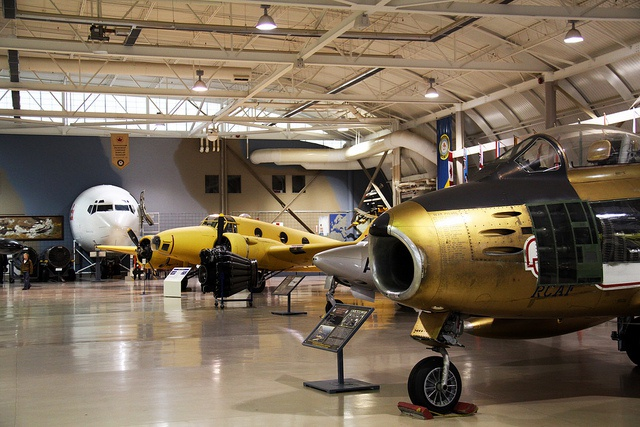Describe the objects in this image and their specific colors. I can see airplane in gray, black, maroon, and olive tones, airplane in gray, orange, maroon, black, and khaki tones, airplane in gray, lightgray, black, and darkgray tones, airplane in gray and black tones, and airplane in gray, black, maroon, and olive tones in this image. 